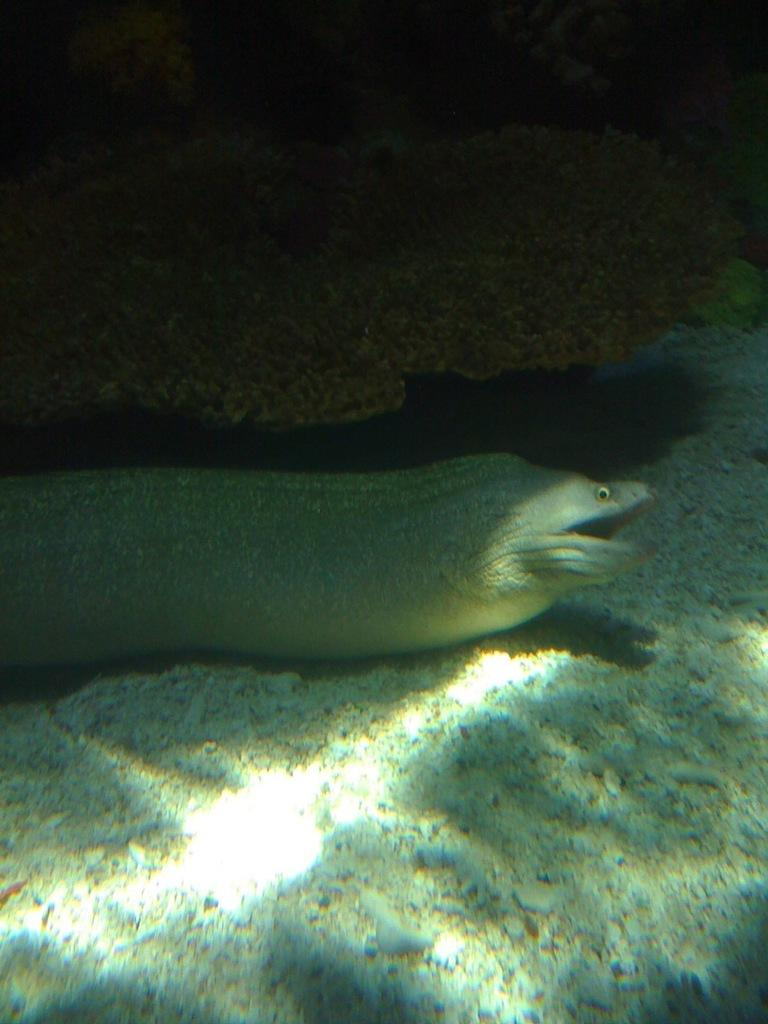What type of animal can be seen in the water in the image? There is an eel in the water in the image. What type of marine structure is visible in the image? There is a coral in the image. What type of plants can be seen growing on the eel in the image? There are no plants visible on the eel in the image. What substance is the eel using to communicate with the coral in the image? There is no indication of any substance being used for communication between the eel and the coral in the image. 